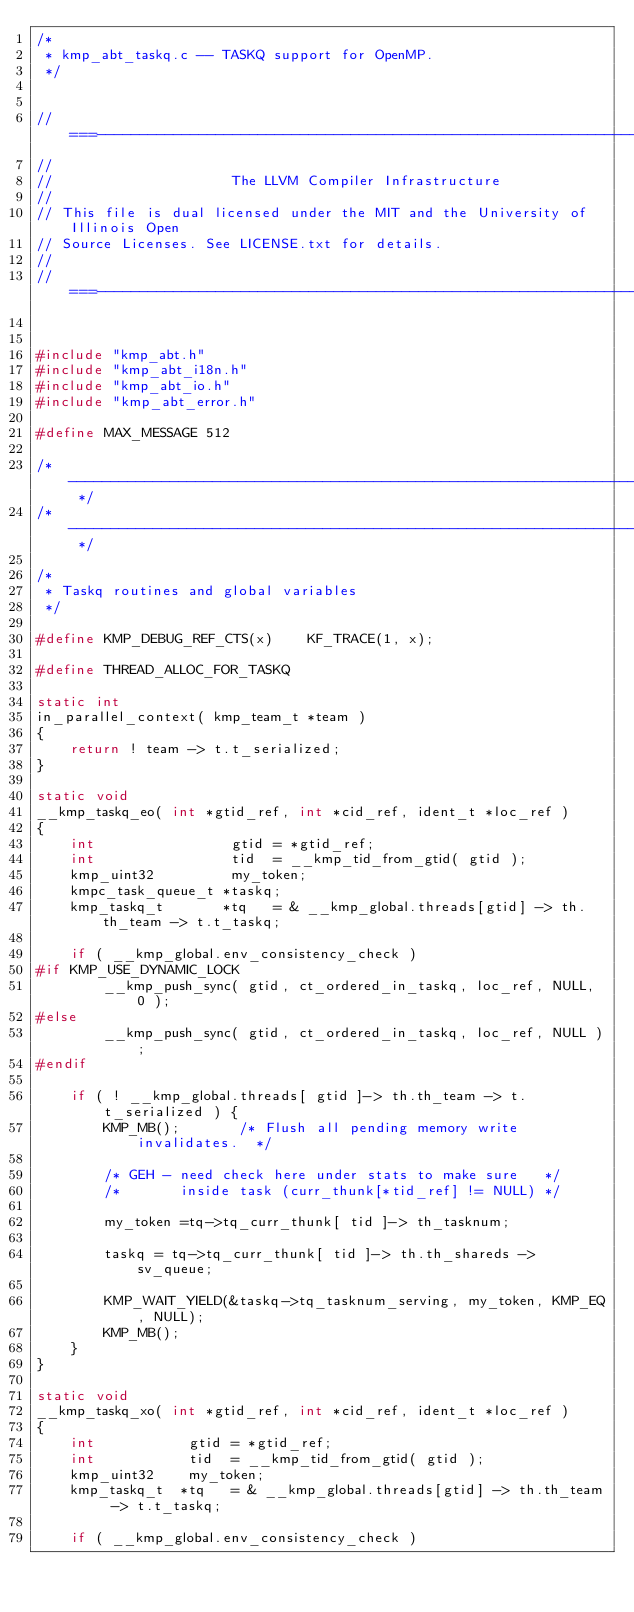<code> <loc_0><loc_0><loc_500><loc_500><_C_>/*
 * kmp_abt_taskq.c -- TASKQ support for OpenMP.
 */


//===----------------------------------------------------------------------===//
//
//                     The LLVM Compiler Infrastructure
//
// This file is dual licensed under the MIT and the University of Illinois Open
// Source Licenses. See LICENSE.txt for details.
//
//===----------------------------------------------------------------------===//


#include "kmp_abt.h"
#include "kmp_abt_i18n.h"
#include "kmp_abt_io.h"
#include "kmp_abt_error.h"

#define MAX_MESSAGE 512

/* ------------------------------------------------------------------------ */
/* ------------------------------------------------------------------------ */

/*
 * Taskq routines and global variables
 */

#define KMP_DEBUG_REF_CTS(x)    KF_TRACE(1, x);

#define THREAD_ALLOC_FOR_TASKQ

static int
in_parallel_context( kmp_team_t *team )
{
    return ! team -> t.t_serialized;
}

static void
__kmp_taskq_eo( int *gtid_ref, int *cid_ref, ident_t *loc_ref )
{
    int                gtid = *gtid_ref;
    int                tid  = __kmp_tid_from_gtid( gtid );
    kmp_uint32         my_token;
    kmpc_task_queue_t *taskq;
    kmp_taskq_t       *tq   = & __kmp_global.threads[gtid] -> th.th_team -> t.t_taskq;

    if ( __kmp_global.env_consistency_check )
#if KMP_USE_DYNAMIC_LOCK
        __kmp_push_sync( gtid, ct_ordered_in_taskq, loc_ref, NULL, 0 );
#else
        __kmp_push_sync( gtid, ct_ordered_in_taskq, loc_ref, NULL );
#endif

    if ( ! __kmp_global.threads[ gtid ]-> th.th_team -> t.t_serialized ) {
        KMP_MB();       /* Flush all pending memory write invalidates.  */

        /* GEH - need check here under stats to make sure   */
        /*       inside task (curr_thunk[*tid_ref] != NULL) */

        my_token =tq->tq_curr_thunk[ tid ]-> th_tasknum;

        taskq = tq->tq_curr_thunk[ tid ]-> th.th_shareds -> sv_queue;

        KMP_WAIT_YIELD(&taskq->tq_tasknum_serving, my_token, KMP_EQ, NULL);
        KMP_MB();
    }
}

static void
__kmp_taskq_xo( int *gtid_ref, int *cid_ref, ident_t *loc_ref )
{
    int           gtid = *gtid_ref;
    int           tid  = __kmp_tid_from_gtid( gtid );
    kmp_uint32    my_token;
    kmp_taskq_t  *tq   = & __kmp_global.threads[gtid] -> th.th_team -> t.t_taskq;

    if ( __kmp_global.env_consistency_check )</code> 